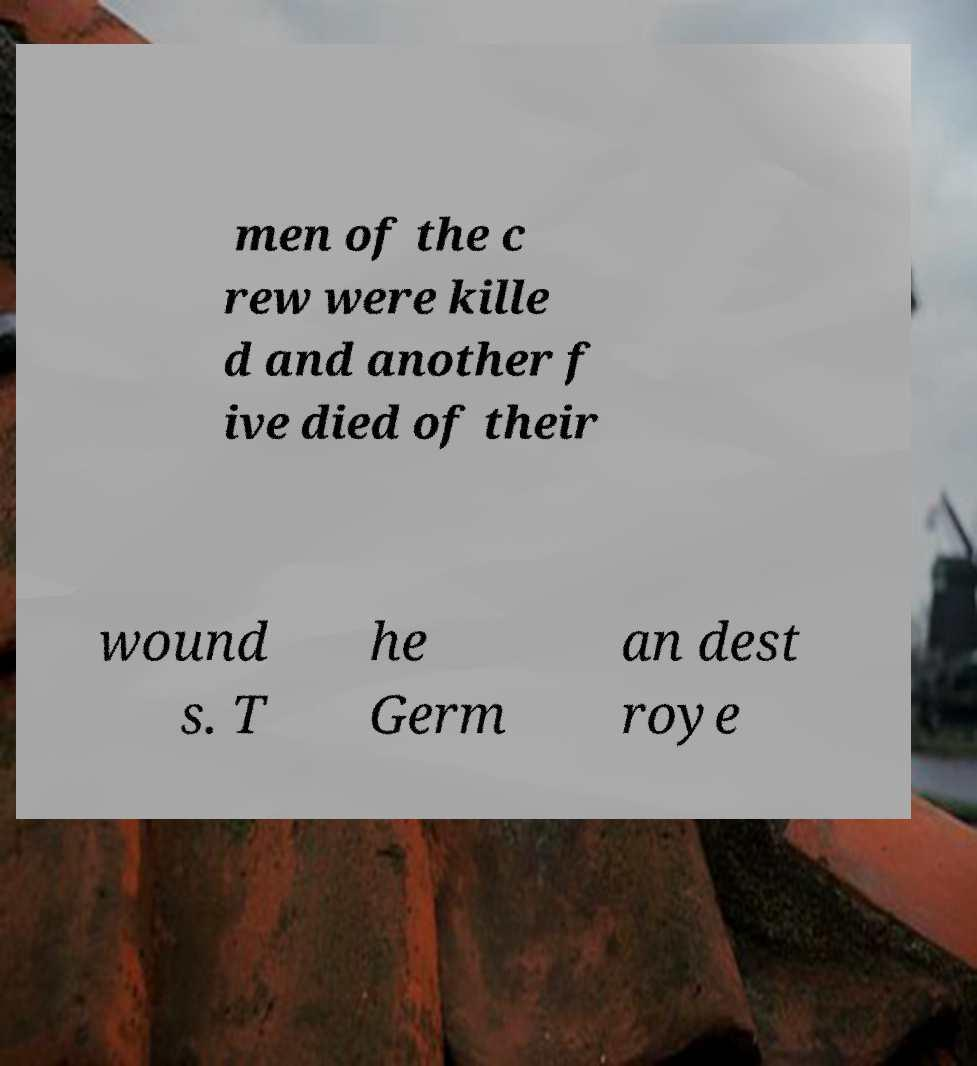Could you assist in decoding the text presented in this image and type it out clearly? men of the c rew were kille d and another f ive died of their wound s. T he Germ an dest roye 